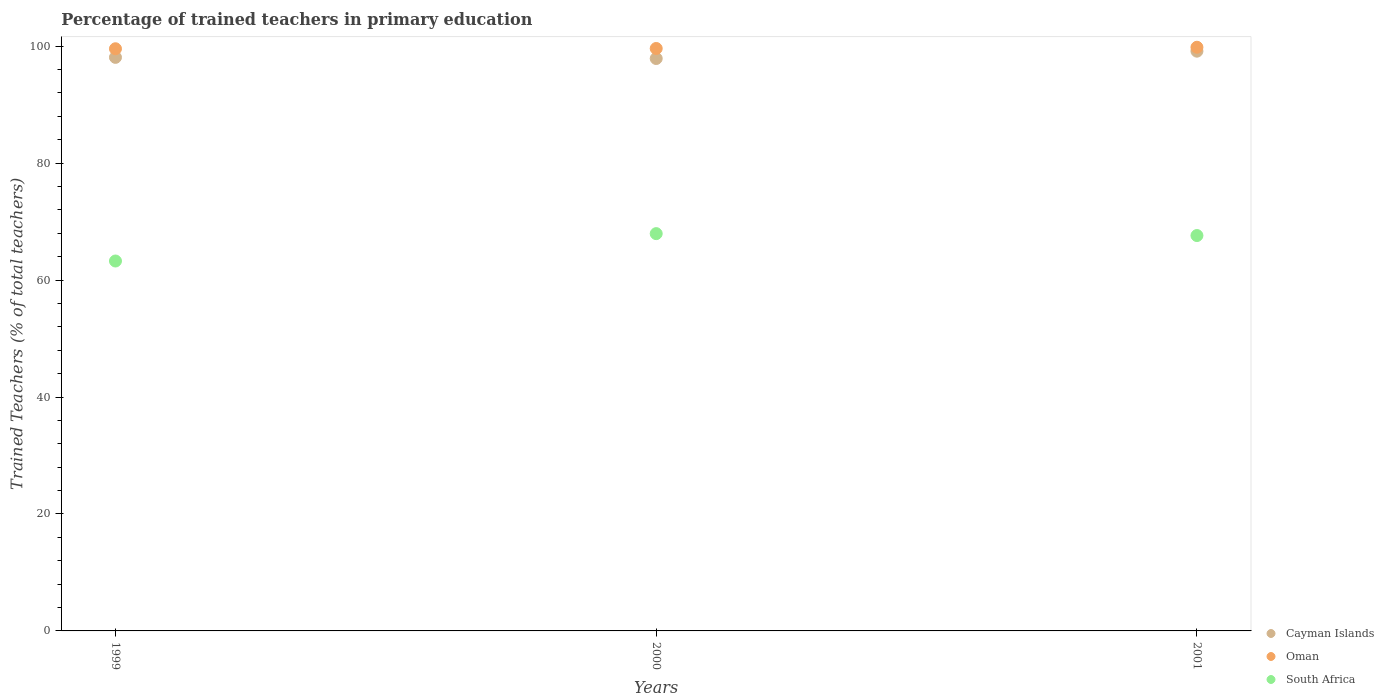How many different coloured dotlines are there?
Offer a terse response. 3. What is the percentage of trained teachers in South Africa in 2000?
Give a very brief answer. 67.94. Across all years, what is the maximum percentage of trained teachers in South Africa?
Your response must be concise. 67.94. Across all years, what is the minimum percentage of trained teachers in Oman?
Your answer should be compact. 99.56. In which year was the percentage of trained teachers in Oman maximum?
Ensure brevity in your answer.  2001. In which year was the percentage of trained teachers in Oman minimum?
Offer a very short reply. 1999. What is the total percentage of trained teachers in Oman in the graph?
Offer a very short reply. 298.97. What is the difference between the percentage of trained teachers in South Africa in 1999 and that in 2000?
Provide a succinct answer. -4.68. What is the difference between the percentage of trained teachers in Cayman Islands in 1999 and the percentage of trained teachers in South Africa in 2001?
Ensure brevity in your answer.  30.47. What is the average percentage of trained teachers in South Africa per year?
Offer a terse response. 66.27. In the year 2001, what is the difference between the percentage of trained teachers in South Africa and percentage of trained teachers in Cayman Islands?
Keep it short and to the point. -31.53. What is the ratio of the percentage of trained teachers in South Africa in 1999 to that in 2000?
Keep it short and to the point. 0.93. What is the difference between the highest and the second highest percentage of trained teachers in Cayman Islands?
Give a very brief answer. 1.06. What is the difference between the highest and the lowest percentage of trained teachers in South Africa?
Your answer should be compact. 4.68. Is it the case that in every year, the sum of the percentage of trained teachers in Cayman Islands and percentage of trained teachers in Oman  is greater than the percentage of trained teachers in South Africa?
Your answer should be very brief. Yes. Is the percentage of trained teachers in South Africa strictly greater than the percentage of trained teachers in Cayman Islands over the years?
Provide a short and direct response. No. What is the difference between two consecutive major ticks on the Y-axis?
Your response must be concise. 20. Are the values on the major ticks of Y-axis written in scientific E-notation?
Keep it short and to the point. No. Does the graph contain any zero values?
Provide a succinct answer. No. How many legend labels are there?
Your answer should be very brief. 3. How are the legend labels stacked?
Offer a terse response. Vertical. What is the title of the graph?
Provide a succinct answer. Percentage of trained teachers in primary education. What is the label or title of the X-axis?
Make the answer very short. Years. What is the label or title of the Y-axis?
Make the answer very short. Trained Teachers (% of total teachers). What is the Trained Teachers (% of total teachers) in Cayman Islands in 1999?
Ensure brevity in your answer.  98.09. What is the Trained Teachers (% of total teachers) of Oman in 1999?
Offer a very short reply. 99.56. What is the Trained Teachers (% of total teachers) in South Africa in 1999?
Keep it short and to the point. 63.26. What is the Trained Teachers (% of total teachers) in Cayman Islands in 2000?
Keep it short and to the point. 97.89. What is the Trained Teachers (% of total teachers) in Oman in 2000?
Offer a terse response. 99.6. What is the Trained Teachers (% of total teachers) of South Africa in 2000?
Ensure brevity in your answer.  67.94. What is the Trained Teachers (% of total teachers) of Cayman Islands in 2001?
Give a very brief answer. 99.15. What is the Trained Teachers (% of total teachers) in Oman in 2001?
Offer a terse response. 99.81. What is the Trained Teachers (% of total teachers) of South Africa in 2001?
Ensure brevity in your answer.  67.62. Across all years, what is the maximum Trained Teachers (% of total teachers) of Cayman Islands?
Your response must be concise. 99.15. Across all years, what is the maximum Trained Teachers (% of total teachers) of Oman?
Provide a succinct answer. 99.81. Across all years, what is the maximum Trained Teachers (% of total teachers) in South Africa?
Give a very brief answer. 67.94. Across all years, what is the minimum Trained Teachers (% of total teachers) in Cayman Islands?
Keep it short and to the point. 97.89. Across all years, what is the minimum Trained Teachers (% of total teachers) of Oman?
Provide a succinct answer. 99.56. Across all years, what is the minimum Trained Teachers (% of total teachers) of South Africa?
Provide a short and direct response. 63.26. What is the total Trained Teachers (% of total teachers) in Cayman Islands in the graph?
Offer a terse response. 295.12. What is the total Trained Teachers (% of total teachers) of Oman in the graph?
Offer a terse response. 298.97. What is the total Trained Teachers (% of total teachers) in South Africa in the graph?
Provide a short and direct response. 198.82. What is the difference between the Trained Teachers (% of total teachers) in Cayman Islands in 1999 and that in 2000?
Your answer should be very brief. 0.2. What is the difference between the Trained Teachers (% of total teachers) in Oman in 1999 and that in 2000?
Make the answer very short. -0.05. What is the difference between the Trained Teachers (% of total teachers) in South Africa in 1999 and that in 2000?
Give a very brief answer. -4.68. What is the difference between the Trained Teachers (% of total teachers) of Cayman Islands in 1999 and that in 2001?
Your response must be concise. -1.06. What is the difference between the Trained Teachers (% of total teachers) of Oman in 1999 and that in 2001?
Provide a succinct answer. -0.26. What is the difference between the Trained Teachers (% of total teachers) of South Africa in 1999 and that in 2001?
Ensure brevity in your answer.  -4.36. What is the difference between the Trained Teachers (% of total teachers) in Cayman Islands in 2000 and that in 2001?
Give a very brief answer. -1.25. What is the difference between the Trained Teachers (% of total teachers) of Oman in 2000 and that in 2001?
Your answer should be very brief. -0.21. What is the difference between the Trained Teachers (% of total teachers) in South Africa in 2000 and that in 2001?
Provide a succinct answer. 0.33. What is the difference between the Trained Teachers (% of total teachers) of Cayman Islands in 1999 and the Trained Teachers (% of total teachers) of Oman in 2000?
Your answer should be very brief. -1.52. What is the difference between the Trained Teachers (% of total teachers) of Cayman Islands in 1999 and the Trained Teachers (% of total teachers) of South Africa in 2000?
Provide a succinct answer. 30.14. What is the difference between the Trained Teachers (% of total teachers) of Oman in 1999 and the Trained Teachers (% of total teachers) of South Africa in 2000?
Provide a short and direct response. 31.62. What is the difference between the Trained Teachers (% of total teachers) in Cayman Islands in 1999 and the Trained Teachers (% of total teachers) in Oman in 2001?
Keep it short and to the point. -1.73. What is the difference between the Trained Teachers (% of total teachers) of Cayman Islands in 1999 and the Trained Teachers (% of total teachers) of South Africa in 2001?
Offer a very short reply. 30.47. What is the difference between the Trained Teachers (% of total teachers) of Oman in 1999 and the Trained Teachers (% of total teachers) of South Africa in 2001?
Your response must be concise. 31.94. What is the difference between the Trained Teachers (% of total teachers) of Cayman Islands in 2000 and the Trained Teachers (% of total teachers) of Oman in 2001?
Keep it short and to the point. -1.92. What is the difference between the Trained Teachers (% of total teachers) of Cayman Islands in 2000 and the Trained Teachers (% of total teachers) of South Africa in 2001?
Your answer should be compact. 30.27. What is the difference between the Trained Teachers (% of total teachers) of Oman in 2000 and the Trained Teachers (% of total teachers) of South Africa in 2001?
Provide a succinct answer. 31.99. What is the average Trained Teachers (% of total teachers) in Cayman Islands per year?
Provide a short and direct response. 98.37. What is the average Trained Teachers (% of total teachers) of Oman per year?
Your answer should be compact. 99.66. What is the average Trained Teachers (% of total teachers) in South Africa per year?
Give a very brief answer. 66.27. In the year 1999, what is the difference between the Trained Teachers (% of total teachers) of Cayman Islands and Trained Teachers (% of total teachers) of Oman?
Keep it short and to the point. -1.47. In the year 1999, what is the difference between the Trained Teachers (% of total teachers) in Cayman Islands and Trained Teachers (% of total teachers) in South Africa?
Provide a succinct answer. 34.83. In the year 1999, what is the difference between the Trained Teachers (% of total teachers) in Oman and Trained Teachers (% of total teachers) in South Africa?
Provide a short and direct response. 36.3. In the year 2000, what is the difference between the Trained Teachers (% of total teachers) of Cayman Islands and Trained Teachers (% of total teachers) of Oman?
Keep it short and to the point. -1.71. In the year 2000, what is the difference between the Trained Teachers (% of total teachers) of Cayman Islands and Trained Teachers (% of total teachers) of South Africa?
Provide a short and direct response. 29.95. In the year 2000, what is the difference between the Trained Teachers (% of total teachers) of Oman and Trained Teachers (% of total teachers) of South Africa?
Give a very brief answer. 31.66. In the year 2001, what is the difference between the Trained Teachers (% of total teachers) in Cayman Islands and Trained Teachers (% of total teachers) in Oman?
Keep it short and to the point. -0.67. In the year 2001, what is the difference between the Trained Teachers (% of total teachers) of Cayman Islands and Trained Teachers (% of total teachers) of South Africa?
Offer a terse response. 31.53. In the year 2001, what is the difference between the Trained Teachers (% of total teachers) of Oman and Trained Teachers (% of total teachers) of South Africa?
Provide a succinct answer. 32.2. What is the ratio of the Trained Teachers (% of total teachers) in South Africa in 1999 to that in 2000?
Make the answer very short. 0.93. What is the ratio of the Trained Teachers (% of total teachers) in Cayman Islands in 1999 to that in 2001?
Your answer should be very brief. 0.99. What is the ratio of the Trained Teachers (% of total teachers) in South Africa in 1999 to that in 2001?
Your answer should be compact. 0.94. What is the ratio of the Trained Teachers (% of total teachers) of Cayman Islands in 2000 to that in 2001?
Keep it short and to the point. 0.99. What is the ratio of the Trained Teachers (% of total teachers) of Oman in 2000 to that in 2001?
Provide a succinct answer. 1. What is the difference between the highest and the second highest Trained Teachers (% of total teachers) in Cayman Islands?
Keep it short and to the point. 1.06. What is the difference between the highest and the second highest Trained Teachers (% of total teachers) of Oman?
Offer a very short reply. 0.21. What is the difference between the highest and the second highest Trained Teachers (% of total teachers) of South Africa?
Provide a succinct answer. 0.33. What is the difference between the highest and the lowest Trained Teachers (% of total teachers) of Cayman Islands?
Make the answer very short. 1.25. What is the difference between the highest and the lowest Trained Teachers (% of total teachers) of Oman?
Make the answer very short. 0.26. What is the difference between the highest and the lowest Trained Teachers (% of total teachers) in South Africa?
Give a very brief answer. 4.68. 